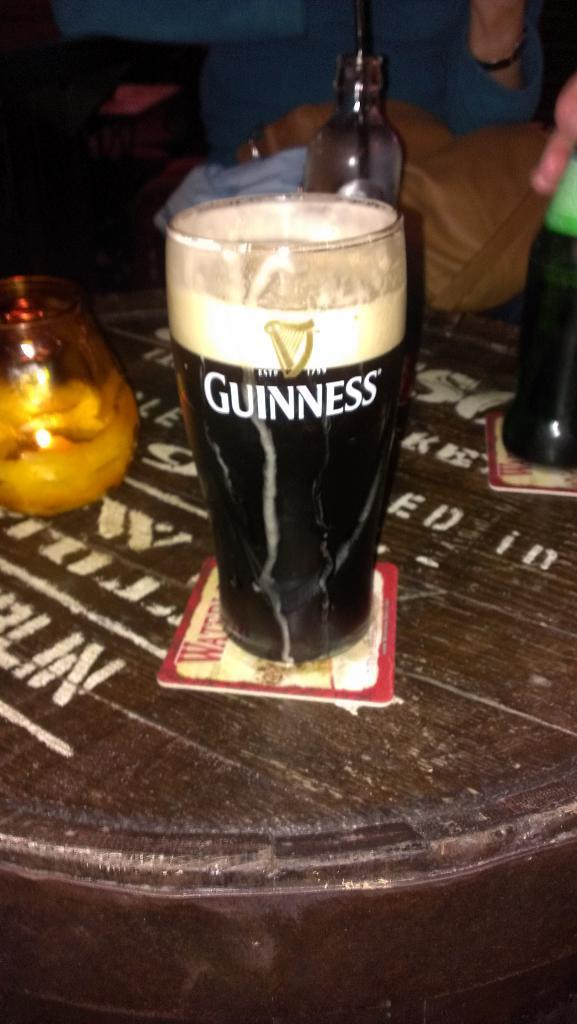What is on the mat in the image? There is a glass with a label on a mat in the image. Where is the glass located? The glass is on a table in the image. What is behind the glass? There is a bowl behind the glass in the image. What else can be seen behind the bowl? There are other glasses behind the bowl in the image. What is behind the other glasses? There is a bag behind the other glasses in the image. What type of coal can be seen in the image? There is no coal present in the image. Can you touch the glass in the image? You cannot touch the glass in the image, as it is a two-dimensional representation. 